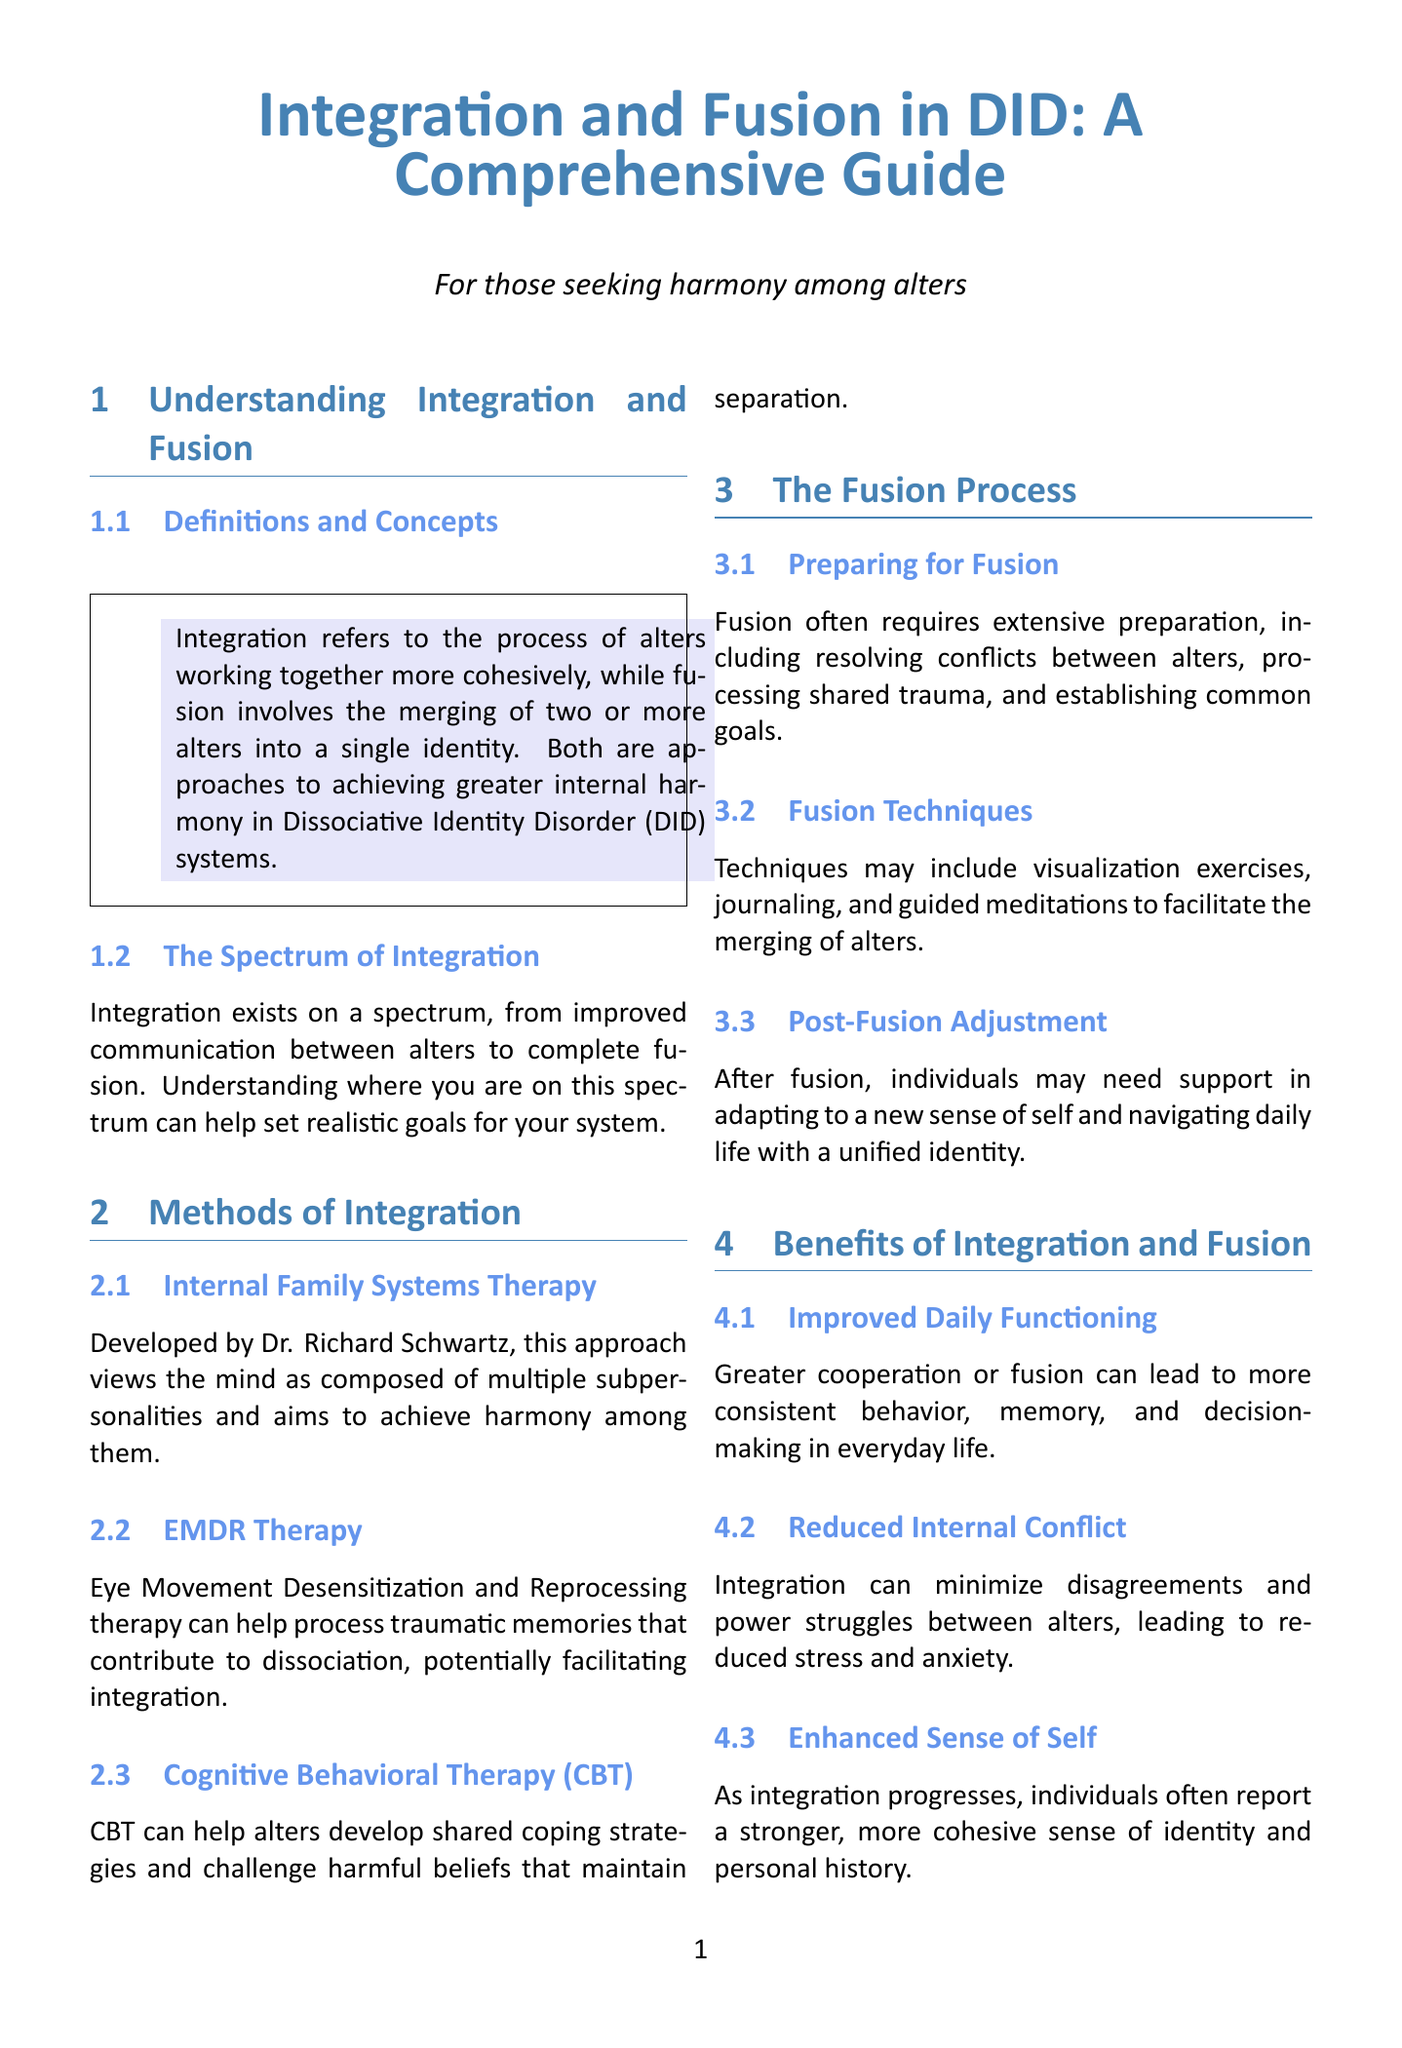What is the main goal of integration? Integration refers to the process of alters working together more cohesively, which aims to achieve greater internal harmony in Dissociative Identity Disorder systems.
Answer: Greater internal harmony Who developed Internal Family Systems Therapy? Internal Family Systems Therapy was developed by Dr. Richard Schwartz.
Answer: Dr. Richard Schwartz What is the first step in the fusion process? Fusion often requires extensive preparation, including resolving conflicts between alters.
Answer: Resolving conflicts What therapy can help process traumatic memories? Eye Movement Desensitization and Reprocessing therapy can help process traumatic memories.
Answer: EMDR Therapy What is a potential risk of integration? Integration could temporarily increase vulnerability as these functions are redistributed.
Answer: Loss of Protective Functions What can improved integration lead to? Greater cooperation or fusion can lead to more consistent behavior, memory, and decision-making.
Answer: Improved Daily Functioning How can alters communicate without full integration? Focusing on enhancing communication and cooperation between alters without pursuing full integration.
Answer: Internal Communication Improvement What type of support is recommended for DID systems? Working with therapists specialized in dissociative disorders.
Answer: Professional Support 